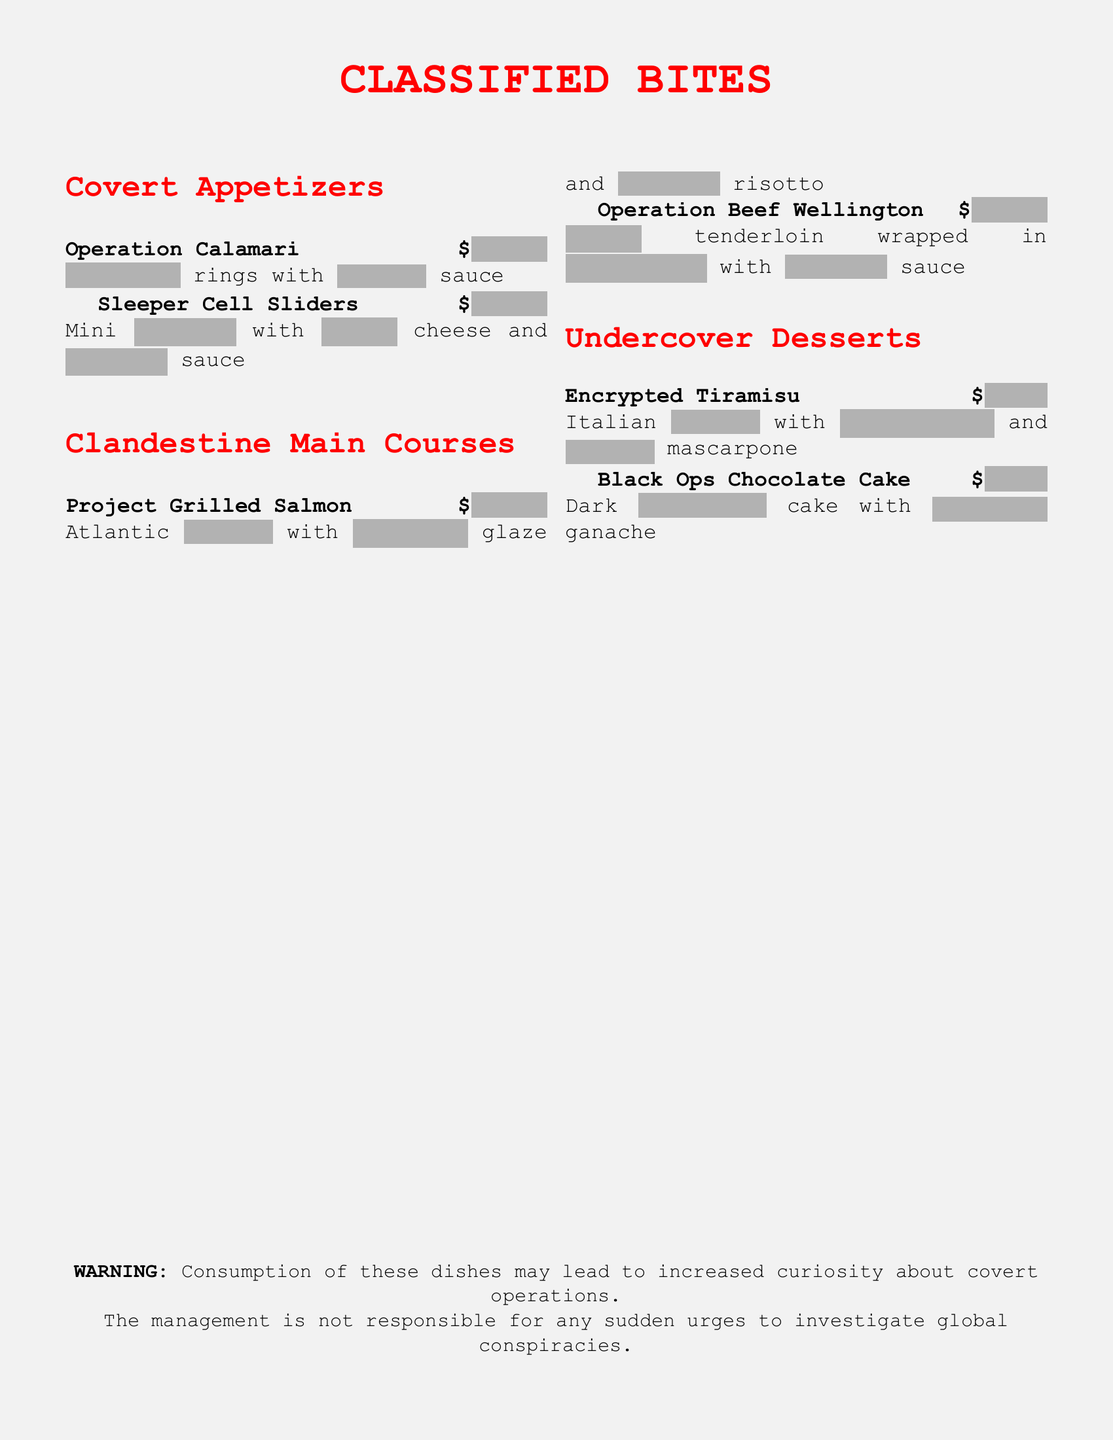What is the title of the menu? The title is prominently displayed at the top of the document, indicating the type of offerings.
Answer: CLASSIFIED BITES How much do the Sleeper Cell Sliders cost? The price for the Sleeper Cell Sliders is provided alongside the dish description.
Answer: $12.99 What type of fish is featured in Project Grilled Salmon? The specific type of fish is mentioned in the dish's title and description.
Answer: salmon What preparation style is used for Operation Beef Wellington? The preparation method is indicated in the dish description.
Answer: wrapped What is the price of the Black Ops Chocolate Cake? The price is explicitly stated next to the dessert name.
Answer: $9.99 Which appetizer is associated with calamari? The specific appetizer name including calamari is listed in the menu.
Answer: Operation Calamari How many main courses are listed in the document? The number of main courses can be counted from the main courses section.
Answer: 2 What is the first item listed under Undercover Desserts? The order of items is visible, with the first dessert mentioned specifically.
Answer: Encrypted Tiramisu What special warning is provided at the bottom of the document? The warning section details a humorous consequence related to the menu items.
Answer: Consumption may lead to increased curiosity about covert operations 